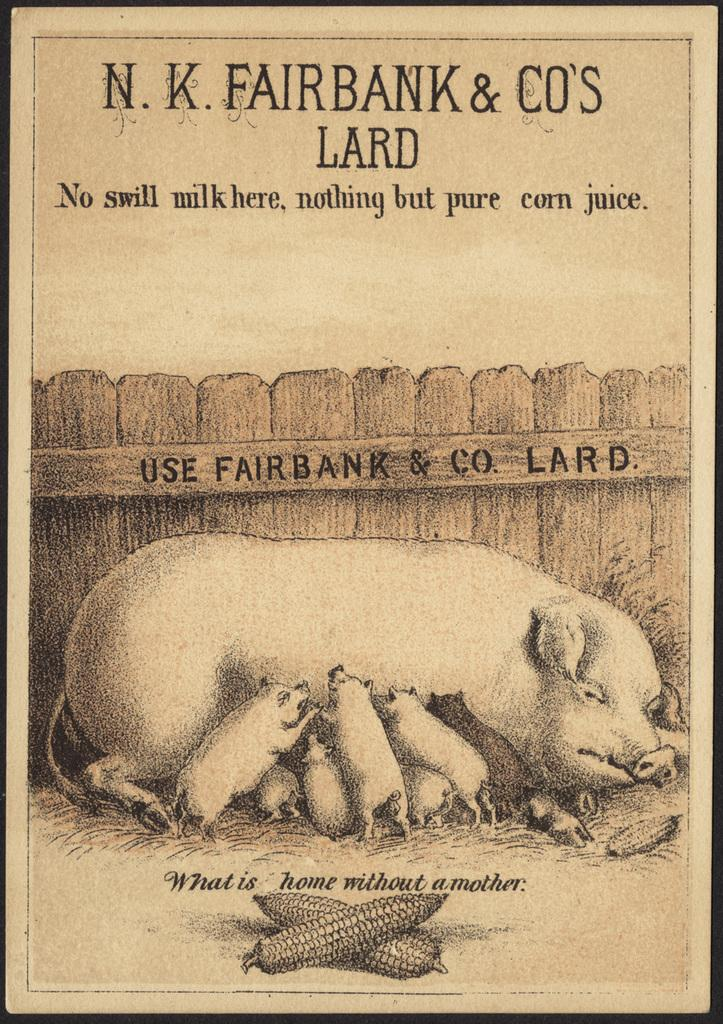What is depicted on the poster in the image? The poster contains pigs, maizes, plants, and fencing. What other elements are present on the poster? There is text on the poster. How are the poster's contents framed in the image? The image has black color borders. What channel is the pig watching on the poster? There is no television or channel depicted on the poster; it only contains images of pigs, maizes, plants, and fencing. Does the poster express any negative emotions, such as hate? The poster does not express any emotions, as it is a visual representation of pigs, maizes, plants, and fencing with accompanying text. 